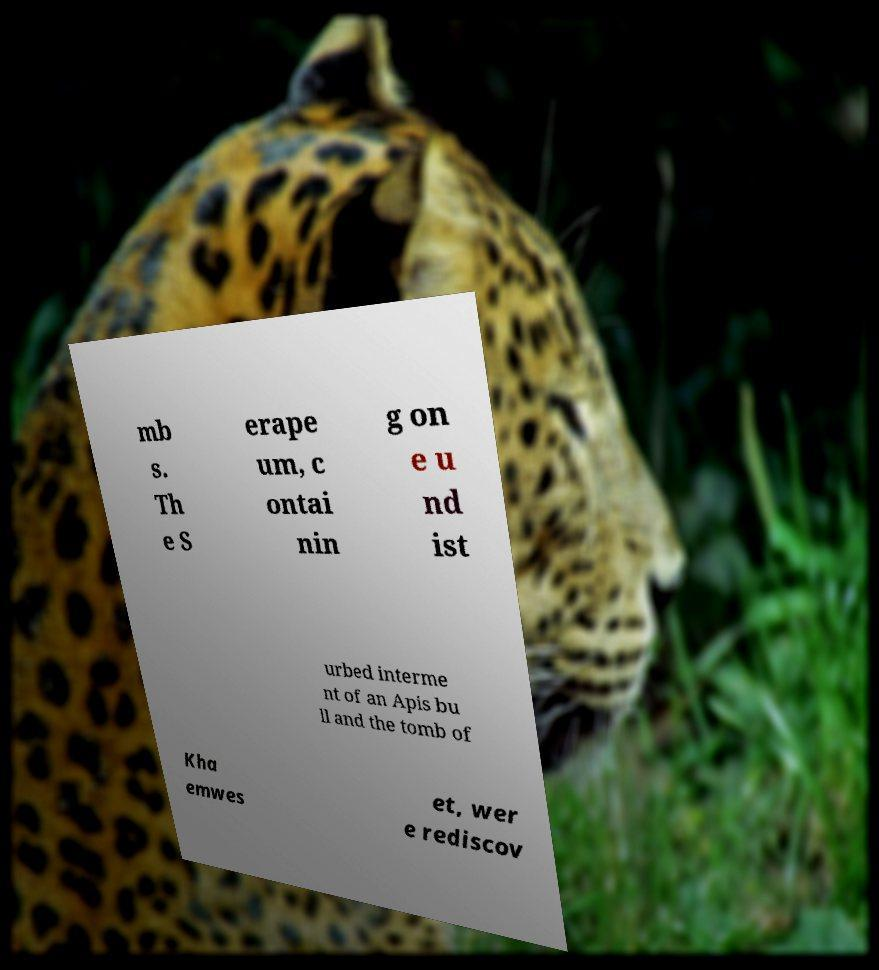Could you assist in decoding the text presented in this image and type it out clearly? mb s. Th e S erape um, c ontai nin g on e u nd ist urbed interme nt of an Apis bu ll and the tomb of Kha emwes et, wer e rediscov 